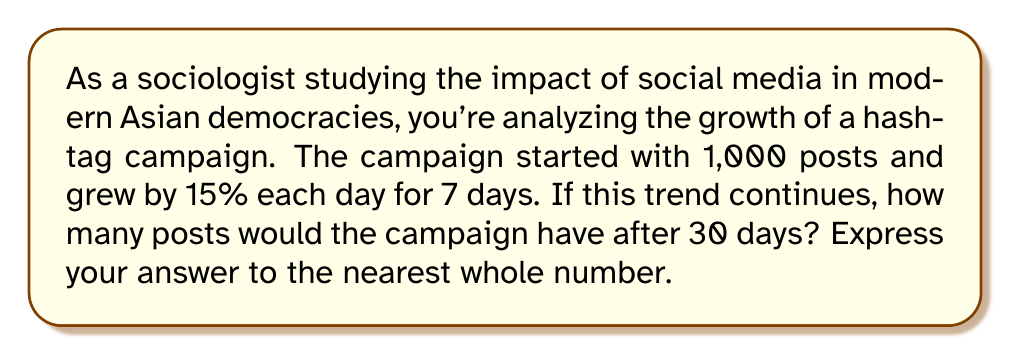Can you answer this question? To solve this problem, we need to use the compound interest formula, which is applicable to exponential growth scenarios like this one. The formula is:

$$A = P(1 + r)^t$$

Where:
$A$ = Final amount
$P$ = Principal (initial amount)
$r$ = Interest rate (in decimal form)
$t$ = Time period

Given:
$P = 1,000$ (initial posts)
$r = 0.15$ (15% daily growth rate)
$t = 30$ (days)

Let's substitute these values into the formula:

$$A = 1,000(1 + 0.15)^{30}$$

Now, let's calculate:

$$A = 1,000(1.15)^{30}$$
$$A = 1,000 \times 66.2117$$
$$A = 66,211.7$$

Rounding to the nearest whole number:

$$A \approx 66,212$$

This means that after 30 days, the hashtag campaign would have approximately 66,212 posts if it continued to grow at the same rate.
Answer: 66,212 posts 